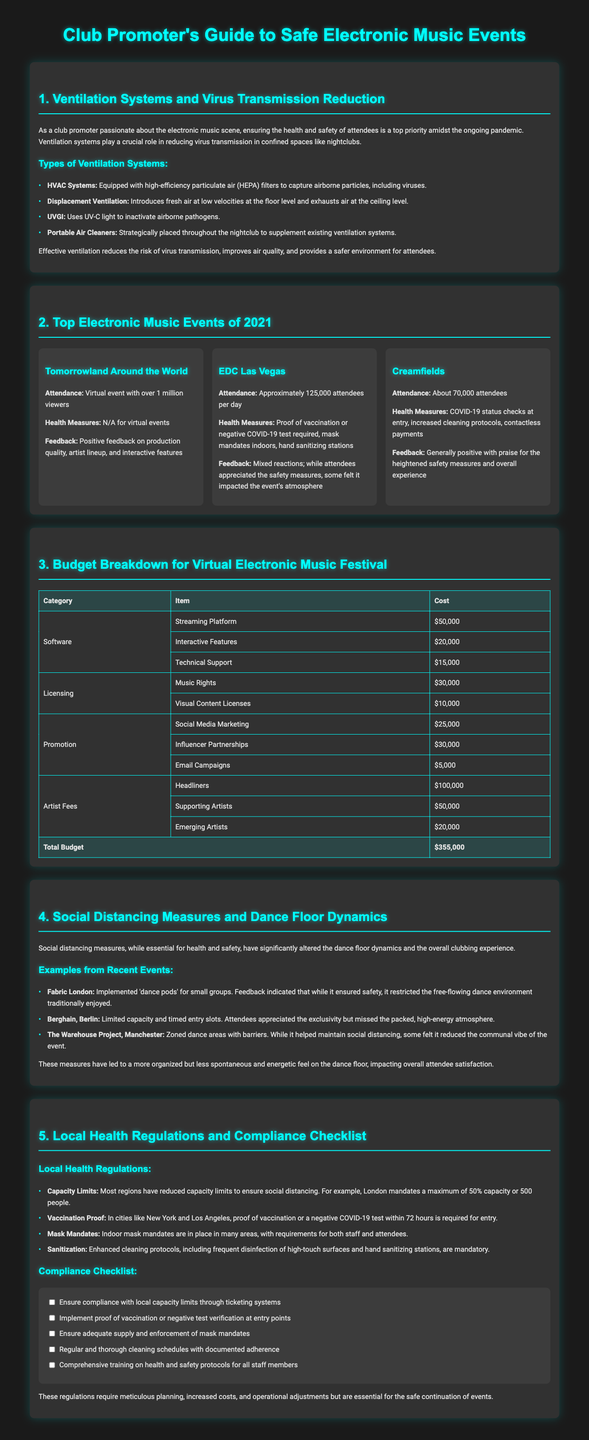What types of ventilation systems are mentioned? The document lists various ventilation technologies specifically relevant to nightclubs, including HVAC Systems, Displacement Ventilation, UVGI, and Portable Air Cleaners.
Answer: HVAC Systems, Displacement Ventilation, UVGI, Portable Air Cleaners What was the attendance for EDC Las Vegas? EDC Las Vegas had an approximate attendance of attendees per day as stated in the document.
Answer: Approximately 125,000 attendees per day What is the total budget for organizing a virtual electronic music festival? The document provides a budget breakdown that totals to $355,000, summarizing all cost categories related to the event.
Answer: $355,000 Which festival had over 1 million viewers? The document names Tomorrowland Around the World as a virtual event that garnered this viewership, highlighting its format.
Answer: Tomorrowland Around the World What health measure was required at entry for events in New York? The document specifies that proof of vaccination or a negative COVID-19 test is mandated for entry at events in New York, reflecting local regulations.
Answer: Proof of vaccination or negative COVID-19 test How did social distancing measures alter the dance floor dynamics? The document discusses specific examples of events that implemented social distancing and notes how it affected the spontaneity and energy of the dance floor.
Answer: Reduced spontaneous energy What was the cost for music rights in the festival budget? The budget breakdown in the document lists the cost for music rights as a specific item under licensing.
Answer: $30,000 What feedback did attendees give regarding Creamfields? The document captures the overall attendee sentiment, emphasizing the praise for heightened safety measures and positive experiences.
Answer: Generally positive 